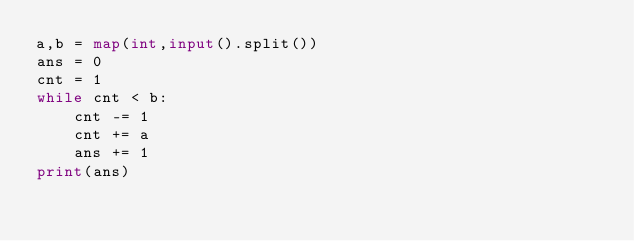Convert code to text. <code><loc_0><loc_0><loc_500><loc_500><_Python_>a,b = map(int,input().split())
ans = 0
cnt = 1
while cnt < b:
    cnt -= 1
    cnt += a
    ans += 1
print(ans)</code> 